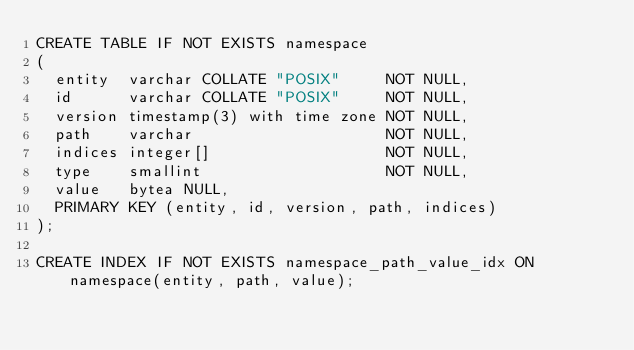<code> <loc_0><loc_0><loc_500><loc_500><_SQL_>CREATE TABLE IF NOT EXISTS namespace
(
  entity  varchar COLLATE "POSIX"     NOT NULL,
  id      varchar COLLATE "POSIX"     NOT NULL,
  version timestamp(3) with time zone NOT NULL,
  path    varchar                     NOT NULL,
  indices integer[]                   NOT NULL,
  type    smallint                    NOT NULL,
  value   bytea NULL,
  PRIMARY KEY (entity, id, version, path, indices)
);

CREATE INDEX IF NOT EXISTS namespace_path_value_idx ON namespace(entity, path, value);</code> 